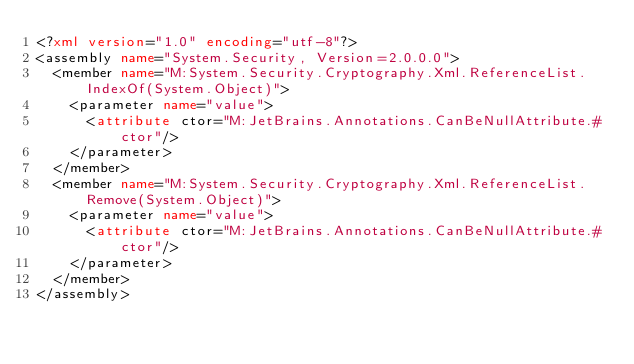Convert code to text. <code><loc_0><loc_0><loc_500><loc_500><_XML_><?xml version="1.0" encoding="utf-8"?>
<assembly name="System.Security, Version=2.0.0.0">
  <member name="M:System.Security.Cryptography.Xml.ReferenceList.IndexOf(System.Object)">
    <parameter name="value">
      <attribute ctor="M:JetBrains.Annotations.CanBeNullAttribute.#ctor"/>
    </parameter>
  </member>
  <member name="M:System.Security.Cryptography.Xml.ReferenceList.Remove(System.Object)">
    <parameter name="value">
      <attribute ctor="M:JetBrains.Annotations.CanBeNullAttribute.#ctor"/>
    </parameter>
  </member>
</assembly>
</code> 